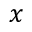<formula> <loc_0><loc_0><loc_500><loc_500>x</formula> 